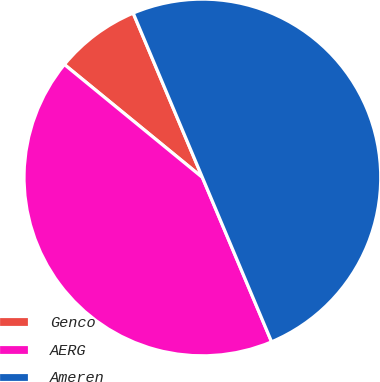<chart> <loc_0><loc_0><loc_500><loc_500><pie_chart><fcel>Genco<fcel>AERG<fcel>Ameren<nl><fcel>7.74%<fcel>42.26%<fcel>50.0%<nl></chart> 